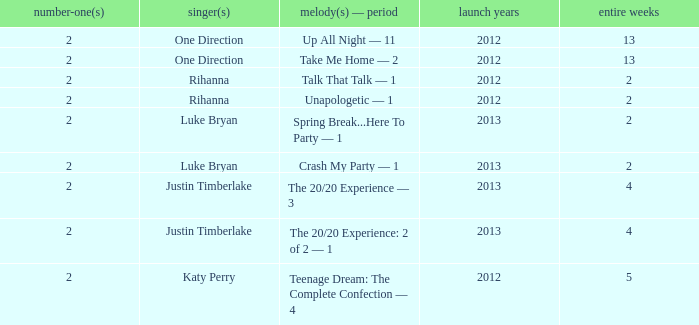What is the longest number of weeks any 1 song was at number #1? 13.0. 